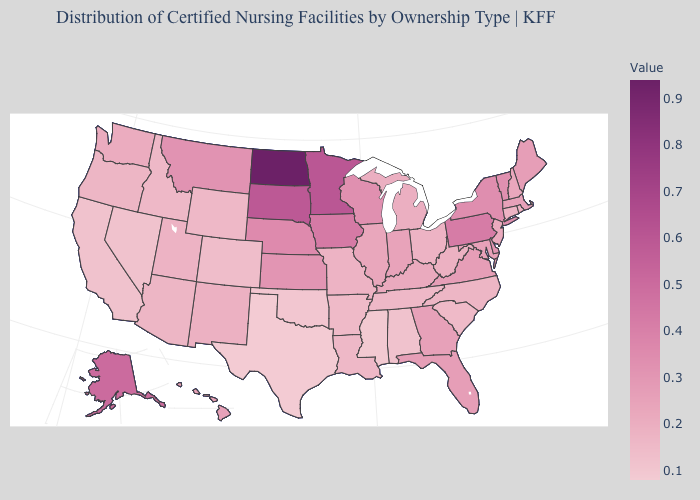Which states hav the highest value in the Northeast?
Concise answer only. Pennsylvania. Does the map have missing data?
Write a very short answer. No. 